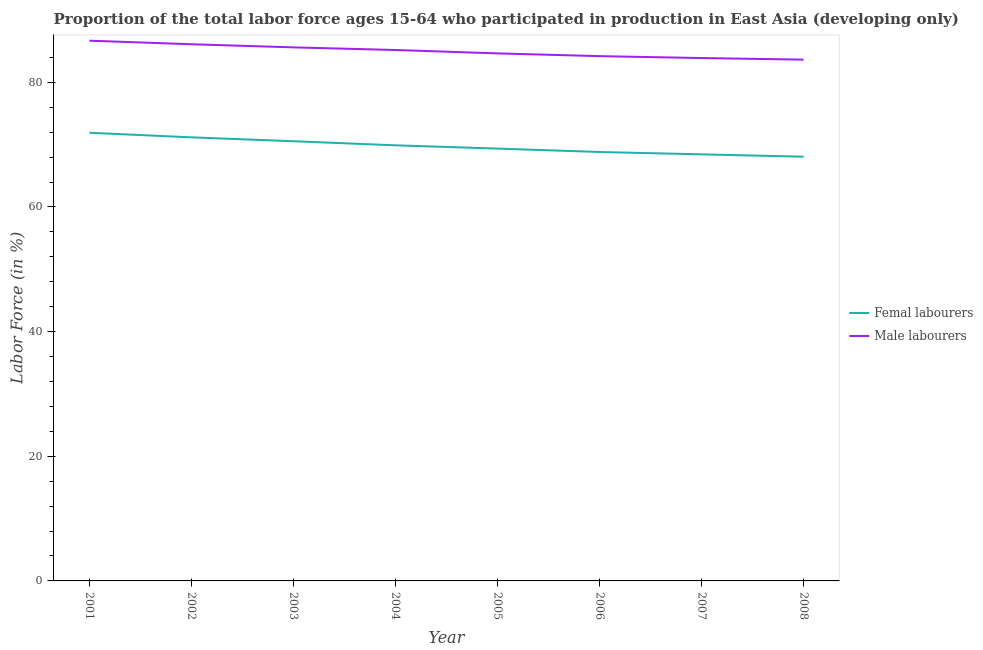What is the percentage of male labour force in 2003?
Give a very brief answer. 85.61. Across all years, what is the maximum percentage of female labor force?
Offer a very short reply. 71.91. Across all years, what is the minimum percentage of male labour force?
Make the answer very short. 83.64. In which year was the percentage of male labour force minimum?
Keep it short and to the point. 2008. What is the total percentage of male labour force in the graph?
Keep it short and to the point. 679.97. What is the difference between the percentage of female labor force in 2001 and that in 2003?
Your response must be concise. 1.36. What is the difference between the percentage of female labor force in 2004 and the percentage of male labour force in 2006?
Ensure brevity in your answer.  -14.31. What is the average percentage of male labour force per year?
Provide a short and direct response. 85. In the year 2004, what is the difference between the percentage of male labour force and percentage of female labor force?
Your answer should be compact. 15.29. What is the ratio of the percentage of female labor force in 2004 to that in 2007?
Make the answer very short. 1.02. Is the difference between the percentage of female labor force in 2002 and 2007 greater than the difference between the percentage of male labour force in 2002 and 2007?
Provide a short and direct response. Yes. What is the difference between the highest and the second highest percentage of male labour force?
Offer a very short reply. 0.57. What is the difference between the highest and the lowest percentage of female labor force?
Ensure brevity in your answer.  3.84. In how many years, is the percentage of male labour force greater than the average percentage of male labour force taken over all years?
Provide a short and direct response. 4. Is the percentage of male labour force strictly greater than the percentage of female labor force over the years?
Provide a short and direct response. Yes. Where does the legend appear in the graph?
Your answer should be very brief. Center right. What is the title of the graph?
Offer a very short reply. Proportion of the total labor force ages 15-64 who participated in production in East Asia (developing only). Does "Not attending school" appear as one of the legend labels in the graph?
Your response must be concise. No. What is the label or title of the X-axis?
Provide a short and direct response. Year. What is the label or title of the Y-axis?
Give a very brief answer. Labor Force (in %). What is the Labor Force (in %) of Femal labourers in 2001?
Your answer should be compact. 71.91. What is the Labor Force (in %) of Male labourers in 2001?
Offer a terse response. 86.68. What is the Labor Force (in %) in Femal labourers in 2002?
Offer a terse response. 71.17. What is the Labor Force (in %) of Male labourers in 2002?
Provide a succinct answer. 86.11. What is the Labor Force (in %) of Femal labourers in 2003?
Make the answer very short. 70.55. What is the Labor Force (in %) in Male labourers in 2003?
Your answer should be very brief. 85.61. What is the Labor Force (in %) of Femal labourers in 2004?
Your response must be concise. 69.89. What is the Labor Force (in %) in Male labourers in 2004?
Provide a short and direct response. 85.19. What is the Labor Force (in %) of Femal labourers in 2005?
Provide a short and direct response. 69.37. What is the Labor Force (in %) in Male labourers in 2005?
Offer a very short reply. 84.64. What is the Labor Force (in %) in Femal labourers in 2006?
Your answer should be very brief. 68.82. What is the Labor Force (in %) in Male labourers in 2006?
Your answer should be compact. 84.2. What is the Labor Force (in %) of Femal labourers in 2007?
Make the answer very short. 68.44. What is the Labor Force (in %) in Male labourers in 2007?
Offer a terse response. 83.9. What is the Labor Force (in %) of Femal labourers in 2008?
Your response must be concise. 68.07. What is the Labor Force (in %) in Male labourers in 2008?
Make the answer very short. 83.64. Across all years, what is the maximum Labor Force (in %) of Femal labourers?
Your answer should be very brief. 71.91. Across all years, what is the maximum Labor Force (in %) in Male labourers?
Offer a terse response. 86.68. Across all years, what is the minimum Labor Force (in %) in Femal labourers?
Ensure brevity in your answer.  68.07. Across all years, what is the minimum Labor Force (in %) in Male labourers?
Your response must be concise. 83.64. What is the total Labor Force (in %) of Femal labourers in the graph?
Provide a succinct answer. 558.22. What is the total Labor Force (in %) in Male labourers in the graph?
Your answer should be compact. 679.97. What is the difference between the Labor Force (in %) in Femal labourers in 2001 and that in 2002?
Offer a terse response. 0.74. What is the difference between the Labor Force (in %) of Male labourers in 2001 and that in 2002?
Provide a succinct answer. 0.57. What is the difference between the Labor Force (in %) in Femal labourers in 2001 and that in 2003?
Keep it short and to the point. 1.36. What is the difference between the Labor Force (in %) of Male labourers in 2001 and that in 2003?
Your response must be concise. 1.07. What is the difference between the Labor Force (in %) in Femal labourers in 2001 and that in 2004?
Provide a short and direct response. 2.02. What is the difference between the Labor Force (in %) in Male labourers in 2001 and that in 2004?
Make the answer very short. 1.5. What is the difference between the Labor Force (in %) in Femal labourers in 2001 and that in 2005?
Provide a short and direct response. 2.54. What is the difference between the Labor Force (in %) in Male labourers in 2001 and that in 2005?
Your answer should be very brief. 2.04. What is the difference between the Labor Force (in %) of Femal labourers in 2001 and that in 2006?
Ensure brevity in your answer.  3.09. What is the difference between the Labor Force (in %) in Male labourers in 2001 and that in 2006?
Keep it short and to the point. 2.48. What is the difference between the Labor Force (in %) of Femal labourers in 2001 and that in 2007?
Keep it short and to the point. 3.47. What is the difference between the Labor Force (in %) of Male labourers in 2001 and that in 2007?
Your answer should be compact. 2.79. What is the difference between the Labor Force (in %) of Femal labourers in 2001 and that in 2008?
Make the answer very short. 3.84. What is the difference between the Labor Force (in %) in Male labourers in 2001 and that in 2008?
Give a very brief answer. 3.04. What is the difference between the Labor Force (in %) in Femal labourers in 2002 and that in 2003?
Make the answer very short. 0.63. What is the difference between the Labor Force (in %) in Male labourers in 2002 and that in 2003?
Keep it short and to the point. 0.5. What is the difference between the Labor Force (in %) of Femal labourers in 2002 and that in 2004?
Provide a short and direct response. 1.28. What is the difference between the Labor Force (in %) of Male labourers in 2002 and that in 2004?
Offer a very short reply. 0.92. What is the difference between the Labor Force (in %) in Femal labourers in 2002 and that in 2005?
Ensure brevity in your answer.  1.81. What is the difference between the Labor Force (in %) of Male labourers in 2002 and that in 2005?
Your answer should be very brief. 1.47. What is the difference between the Labor Force (in %) of Femal labourers in 2002 and that in 2006?
Provide a short and direct response. 2.35. What is the difference between the Labor Force (in %) of Male labourers in 2002 and that in 2006?
Ensure brevity in your answer.  1.91. What is the difference between the Labor Force (in %) of Femal labourers in 2002 and that in 2007?
Ensure brevity in your answer.  2.73. What is the difference between the Labor Force (in %) in Male labourers in 2002 and that in 2007?
Your response must be concise. 2.21. What is the difference between the Labor Force (in %) in Femal labourers in 2002 and that in 2008?
Your answer should be very brief. 3.11. What is the difference between the Labor Force (in %) in Male labourers in 2002 and that in 2008?
Your response must be concise. 2.47. What is the difference between the Labor Force (in %) in Femal labourers in 2003 and that in 2004?
Offer a very short reply. 0.65. What is the difference between the Labor Force (in %) in Male labourers in 2003 and that in 2004?
Your answer should be very brief. 0.42. What is the difference between the Labor Force (in %) of Femal labourers in 2003 and that in 2005?
Keep it short and to the point. 1.18. What is the difference between the Labor Force (in %) of Male labourers in 2003 and that in 2005?
Your response must be concise. 0.97. What is the difference between the Labor Force (in %) in Femal labourers in 2003 and that in 2006?
Keep it short and to the point. 1.73. What is the difference between the Labor Force (in %) of Male labourers in 2003 and that in 2006?
Your response must be concise. 1.41. What is the difference between the Labor Force (in %) of Femal labourers in 2003 and that in 2007?
Give a very brief answer. 2.1. What is the difference between the Labor Force (in %) of Male labourers in 2003 and that in 2007?
Make the answer very short. 1.71. What is the difference between the Labor Force (in %) in Femal labourers in 2003 and that in 2008?
Your answer should be very brief. 2.48. What is the difference between the Labor Force (in %) in Male labourers in 2003 and that in 2008?
Provide a short and direct response. 1.97. What is the difference between the Labor Force (in %) of Femal labourers in 2004 and that in 2005?
Make the answer very short. 0.53. What is the difference between the Labor Force (in %) in Male labourers in 2004 and that in 2005?
Offer a terse response. 0.55. What is the difference between the Labor Force (in %) in Femal labourers in 2004 and that in 2006?
Your response must be concise. 1.07. What is the difference between the Labor Force (in %) of Male labourers in 2004 and that in 2006?
Provide a short and direct response. 0.99. What is the difference between the Labor Force (in %) in Femal labourers in 2004 and that in 2007?
Ensure brevity in your answer.  1.45. What is the difference between the Labor Force (in %) in Male labourers in 2004 and that in 2007?
Your answer should be compact. 1.29. What is the difference between the Labor Force (in %) in Femal labourers in 2004 and that in 2008?
Offer a terse response. 1.83. What is the difference between the Labor Force (in %) in Male labourers in 2004 and that in 2008?
Your answer should be very brief. 1.55. What is the difference between the Labor Force (in %) in Femal labourers in 2005 and that in 2006?
Give a very brief answer. 0.54. What is the difference between the Labor Force (in %) of Male labourers in 2005 and that in 2006?
Offer a terse response. 0.44. What is the difference between the Labor Force (in %) of Femal labourers in 2005 and that in 2007?
Make the answer very short. 0.92. What is the difference between the Labor Force (in %) in Male labourers in 2005 and that in 2007?
Offer a terse response. 0.75. What is the difference between the Labor Force (in %) of Femal labourers in 2005 and that in 2008?
Give a very brief answer. 1.3. What is the difference between the Labor Force (in %) of Femal labourers in 2006 and that in 2007?
Your answer should be compact. 0.38. What is the difference between the Labor Force (in %) in Male labourers in 2006 and that in 2007?
Keep it short and to the point. 0.3. What is the difference between the Labor Force (in %) of Femal labourers in 2006 and that in 2008?
Provide a succinct answer. 0.75. What is the difference between the Labor Force (in %) in Male labourers in 2006 and that in 2008?
Your response must be concise. 0.56. What is the difference between the Labor Force (in %) in Femal labourers in 2007 and that in 2008?
Your answer should be compact. 0.38. What is the difference between the Labor Force (in %) in Male labourers in 2007 and that in 2008?
Your response must be concise. 0.26. What is the difference between the Labor Force (in %) of Femal labourers in 2001 and the Labor Force (in %) of Male labourers in 2002?
Your response must be concise. -14.2. What is the difference between the Labor Force (in %) in Femal labourers in 2001 and the Labor Force (in %) in Male labourers in 2003?
Provide a succinct answer. -13.7. What is the difference between the Labor Force (in %) in Femal labourers in 2001 and the Labor Force (in %) in Male labourers in 2004?
Ensure brevity in your answer.  -13.28. What is the difference between the Labor Force (in %) in Femal labourers in 2001 and the Labor Force (in %) in Male labourers in 2005?
Offer a terse response. -12.73. What is the difference between the Labor Force (in %) of Femal labourers in 2001 and the Labor Force (in %) of Male labourers in 2006?
Your answer should be compact. -12.29. What is the difference between the Labor Force (in %) of Femal labourers in 2001 and the Labor Force (in %) of Male labourers in 2007?
Offer a terse response. -11.99. What is the difference between the Labor Force (in %) in Femal labourers in 2001 and the Labor Force (in %) in Male labourers in 2008?
Provide a succinct answer. -11.73. What is the difference between the Labor Force (in %) of Femal labourers in 2002 and the Labor Force (in %) of Male labourers in 2003?
Keep it short and to the point. -14.44. What is the difference between the Labor Force (in %) in Femal labourers in 2002 and the Labor Force (in %) in Male labourers in 2004?
Give a very brief answer. -14.01. What is the difference between the Labor Force (in %) in Femal labourers in 2002 and the Labor Force (in %) in Male labourers in 2005?
Keep it short and to the point. -13.47. What is the difference between the Labor Force (in %) of Femal labourers in 2002 and the Labor Force (in %) of Male labourers in 2006?
Make the answer very short. -13.03. What is the difference between the Labor Force (in %) of Femal labourers in 2002 and the Labor Force (in %) of Male labourers in 2007?
Your response must be concise. -12.72. What is the difference between the Labor Force (in %) in Femal labourers in 2002 and the Labor Force (in %) in Male labourers in 2008?
Ensure brevity in your answer.  -12.47. What is the difference between the Labor Force (in %) of Femal labourers in 2003 and the Labor Force (in %) of Male labourers in 2004?
Offer a very short reply. -14.64. What is the difference between the Labor Force (in %) in Femal labourers in 2003 and the Labor Force (in %) in Male labourers in 2005?
Provide a succinct answer. -14.09. What is the difference between the Labor Force (in %) of Femal labourers in 2003 and the Labor Force (in %) of Male labourers in 2006?
Your answer should be compact. -13.65. What is the difference between the Labor Force (in %) of Femal labourers in 2003 and the Labor Force (in %) of Male labourers in 2007?
Your answer should be compact. -13.35. What is the difference between the Labor Force (in %) of Femal labourers in 2003 and the Labor Force (in %) of Male labourers in 2008?
Provide a succinct answer. -13.09. What is the difference between the Labor Force (in %) of Femal labourers in 2004 and the Labor Force (in %) of Male labourers in 2005?
Make the answer very short. -14.75. What is the difference between the Labor Force (in %) in Femal labourers in 2004 and the Labor Force (in %) in Male labourers in 2006?
Your answer should be very brief. -14.31. What is the difference between the Labor Force (in %) of Femal labourers in 2004 and the Labor Force (in %) of Male labourers in 2007?
Provide a succinct answer. -14. What is the difference between the Labor Force (in %) of Femal labourers in 2004 and the Labor Force (in %) of Male labourers in 2008?
Your answer should be very brief. -13.75. What is the difference between the Labor Force (in %) of Femal labourers in 2005 and the Labor Force (in %) of Male labourers in 2006?
Your response must be concise. -14.83. What is the difference between the Labor Force (in %) of Femal labourers in 2005 and the Labor Force (in %) of Male labourers in 2007?
Your response must be concise. -14.53. What is the difference between the Labor Force (in %) of Femal labourers in 2005 and the Labor Force (in %) of Male labourers in 2008?
Give a very brief answer. -14.27. What is the difference between the Labor Force (in %) of Femal labourers in 2006 and the Labor Force (in %) of Male labourers in 2007?
Offer a terse response. -15.07. What is the difference between the Labor Force (in %) in Femal labourers in 2006 and the Labor Force (in %) in Male labourers in 2008?
Keep it short and to the point. -14.82. What is the difference between the Labor Force (in %) in Femal labourers in 2007 and the Labor Force (in %) in Male labourers in 2008?
Your answer should be very brief. -15.2. What is the average Labor Force (in %) in Femal labourers per year?
Provide a short and direct response. 69.78. What is the average Labor Force (in %) of Male labourers per year?
Your answer should be compact. 85. In the year 2001, what is the difference between the Labor Force (in %) of Femal labourers and Labor Force (in %) of Male labourers?
Provide a short and direct response. -14.77. In the year 2002, what is the difference between the Labor Force (in %) in Femal labourers and Labor Force (in %) in Male labourers?
Offer a terse response. -14.94. In the year 2003, what is the difference between the Labor Force (in %) in Femal labourers and Labor Force (in %) in Male labourers?
Your answer should be very brief. -15.06. In the year 2004, what is the difference between the Labor Force (in %) of Femal labourers and Labor Force (in %) of Male labourers?
Provide a succinct answer. -15.29. In the year 2005, what is the difference between the Labor Force (in %) in Femal labourers and Labor Force (in %) in Male labourers?
Give a very brief answer. -15.28. In the year 2006, what is the difference between the Labor Force (in %) in Femal labourers and Labor Force (in %) in Male labourers?
Give a very brief answer. -15.38. In the year 2007, what is the difference between the Labor Force (in %) in Femal labourers and Labor Force (in %) in Male labourers?
Provide a short and direct response. -15.45. In the year 2008, what is the difference between the Labor Force (in %) in Femal labourers and Labor Force (in %) in Male labourers?
Your response must be concise. -15.57. What is the ratio of the Labor Force (in %) of Femal labourers in 2001 to that in 2002?
Keep it short and to the point. 1.01. What is the ratio of the Labor Force (in %) in Male labourers in 2001 to that in 2002?
Give a very brief answer. 1.01. What is the ratio of the Labor Force (in %) of Femal labourers in 2001 to that in 2003?
Ensure brevity in your answer.  1.02. What is the ratio of the Labor Force (in %) of Male labourers in 2001 to that in 2003?
Ensure brevity in your answer.  1.01. What is the ratio of the Labor Force (in %) of Femal labourers in 2001 to that in 2004?
Provide a succinct answer. 1.03. What is the ratio of the Labor Force (in %) of Male labourers in 2001 to that in 2004?
Your answer should be compact. 1.02. What is the ratio of the Labor Force (in %) in Femal labourers in 2001 to that in 2005?
Provide a short and direct response. 1.04. What is the ratio of the Labor Force (in %) of Male labourers in 2001 to that in 2005?
Give a very brief answer. 1.02. What is the ratio of the Labor Force (in %) of Femal labourers in 2001 to that in 2006?
Provide a succinct answer. 1.04. What is the ratio of the Labor Force (in %) of Male labourers in 2001 to that in 2006?
Make the answer very short. 1.03. What is the ratio of the Labor Force (in %) in Femal labourers in 2001 to that in 2007?
Provide a succinct answer. 1.05. What is the ratio of the Labor Force (in %) in Male labourers in 2001 to that in 2007?
Your answer should be very brief. 1.03. What is the ratio of the Labor Force (in %) in Femal labourers in 2001 to that in 2008?
Your answer should be very brief. 1.06. What is the ratio of the Labor Force (in %) of Male labourers in 2001 to that in 2008?
Give a very brief answer. 1.04. What is the ratio of the Labor Force (in %) of Femal labourers in 2002 to that in 2003?
Make the answer very short. 1.01. What is the ratio of the Labor Force (in %) of Femal labourers in 2002 to that in 2004?
Your answer should be compact. 1.02. What is the ratio of the Labor Force (in %) of Male labourers in 2002 to that in 2004?
Offer a very short reply. 1.01. What is the ratio of the Labor Force (in %) in Femal labourers in 2002 to that in 2005?
Your answer should be compact. 1.03. What is the ratio of the Labor Force (in %) in Male labourers in 2002 to that in 2005?
Your response must be concise. 1.02. What is the ratio of the Labor Force (in %) of Femal labourers in 2002 to that in 2006?
Your answer should be very brief. 1.03. What is the ratio of the Labor Force (in %) of Male labourers in 2002 to that in 2006?
Offer a very short reply. 1.02. What is the ratio of the Labor Force (in %) in Femal labourers in 2002 to that in 2007?
Provide a succinct answer. 1.04. What is the ratio of the Labor Force (in %) in Male labourers in 2002 to that in 2007?
Ensure brevity in your answer.  1.03. What is the ratio of the Labor Force (in %) in Femal labourers in 2002 to that in 2008?
Your answer should be compact. 1.05. What is the ratio of the Labor Force (in %) in Male labourers in 2002 to that in 2008?
Make the answer very short. 1.03. What is the ratio of the Labor Force (in %) in Femal labourers in 2003 to that in 2004?
Ensure brevity in your answer.  1.01. What is the ratio of the Labor Force (in %) in Male labourers in 2003 to that in 2004?
Ensure brevity in your answer.  1. What is the ratio of the Labor Force (in %) in Male labourers in 2003 to that in 2005?
Provide a short and direct response. 1.01. What is the ratio of the Labor Force (in %) in Femal labourers in 2003 to that in 2006?
Make the answer very short. 1.03. What is the ratio of the Labor Force (in %) in Male labourers in 2003 to that in 2006?
Provide a succinct answer. 1.02. What is the ratio of the Labor Force (in %) of Femal labourers in 2003 to that in 2007?
Give a very brief answer. 1.03. What is the ratio of the Labor Force (in %) of Male labourers in 2003 to that in 2007?
Provide a succinct answer. 1.02. What is the ratio of the Labor Force (in %) of Femal labourers in 2003 to that in 2008?
Provide a succinct answer. 1.04. What is the ratio of the Labor Force (in %) in Male labourers in 2003 to that in 2008?
Give a very brief answer. 1.02. What is the ratio of the Labor Force (in %) in Femal labourers in 2004 to that in 2005?
Offer a terse response. 1.01. What is the ratio of the Labor Force (in %) in Male labourers in 2004 to that in 2005?
Your response must be concise. 1.01. What is the ratio of the Labor Force (in %) in Femal labourers in 2004 to that in 2006?
Make the answer very short. 1.02. What is the ratio of the Labor Force (in %) in Male labourers in 2004 to that in 2006?
Provide a short and direct response. 1.01. What is the ratio of the Labor Force (in %) of Femal labourers in 2004 to that in 2007?
Your answer should be very brief. 1.02. What is the ratio of the Labor Force (in %) of Male labourers in 2004 to that in 2007?
Your answer should be compact. 1.02. What is the ratio of the Labor Force (in %) in Femal labourers in 2004 to that in 2008?
Offer a very short reply. 1.03. What is the ratio of the Labor Force (in %) of Male labourers in 2004 to that in 2008?
Make the answer very short. 1.02. What is the ratio of the Labor Force (in %) in Femal labourers in 2005 to that in 2006?
Your answer should be compact. 1.01. What is the ratio of the Labor Force (in %) of Male labourers in 2005 to that in 2006?
Keep it short and to the point. 1.01. What is the ratio of the Labor Force (in %) in Femal labourers in 2005 to that in 2007?
Make the answer very short. 1.01. What is the ratio of the Labor Force (in %) of Male labourers in 2005 to that in 2007?
Keep it short and to the point. 1.01. What is the ratio of the Labor Force (in %) in Femal labourers in 2005 to that in 2008?
Make the answer very short. 1.02. What is the ratio of the Labor Force (in %) of Male labourers in 2005 to that in 2008?
Offer a very short reply. 1.01. What is the ratio of the Labor Force (in %) in Femal labourers in 2006 to that in 2007?
Offer a terse response. 1.01. What is the ratio of the Labor Force (in %) of Male labourers in 2006 to that in 2007?
Make the answer very short. 1. What is the ratio of the Labor Force (in %) of Femal labourers in 2006 to that in 2008?
Offer a terse response. 1.01. What is the difference between the highest and the second highest Labor Force (in %) in Femal labourers?
Provide a short and direct response. 0.74. What is the difference between the highest and the second highest Labor Force (in %) of Male labourers?
Make the answer very short. 0.57. What is the difference between the highest and the lowest Labor Force (in %) in Femal labourers?
Keep it short and to the point. 3.84. What is the difference between the highest and the lowest Labor Force (in %) in Male labourers?
Provide a succinct answer. 3.04. 